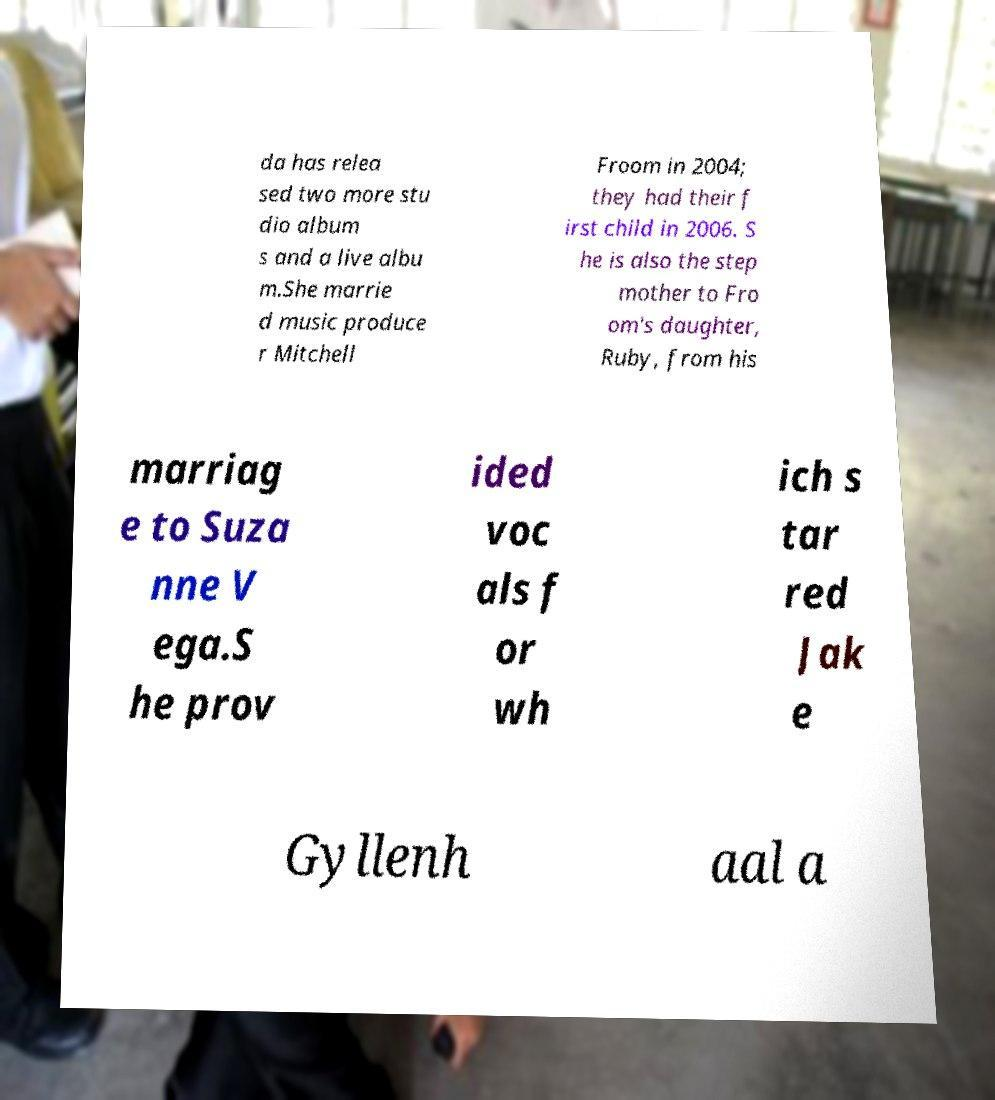What messages or text are displayed in this image? I need them in a readable, typed format. da has relea sed two more stu dio album s and a live albu m.She marrie d music produce r Mitchell Froom in 2004; they had their f irst child in 2006. S he is also the step mother to Fro om's daughter, Ruby, from his marriag e to Suza nne V ega.S he prov ided voc als f or wh ich s tar red Jak e Gyllenh aal a 